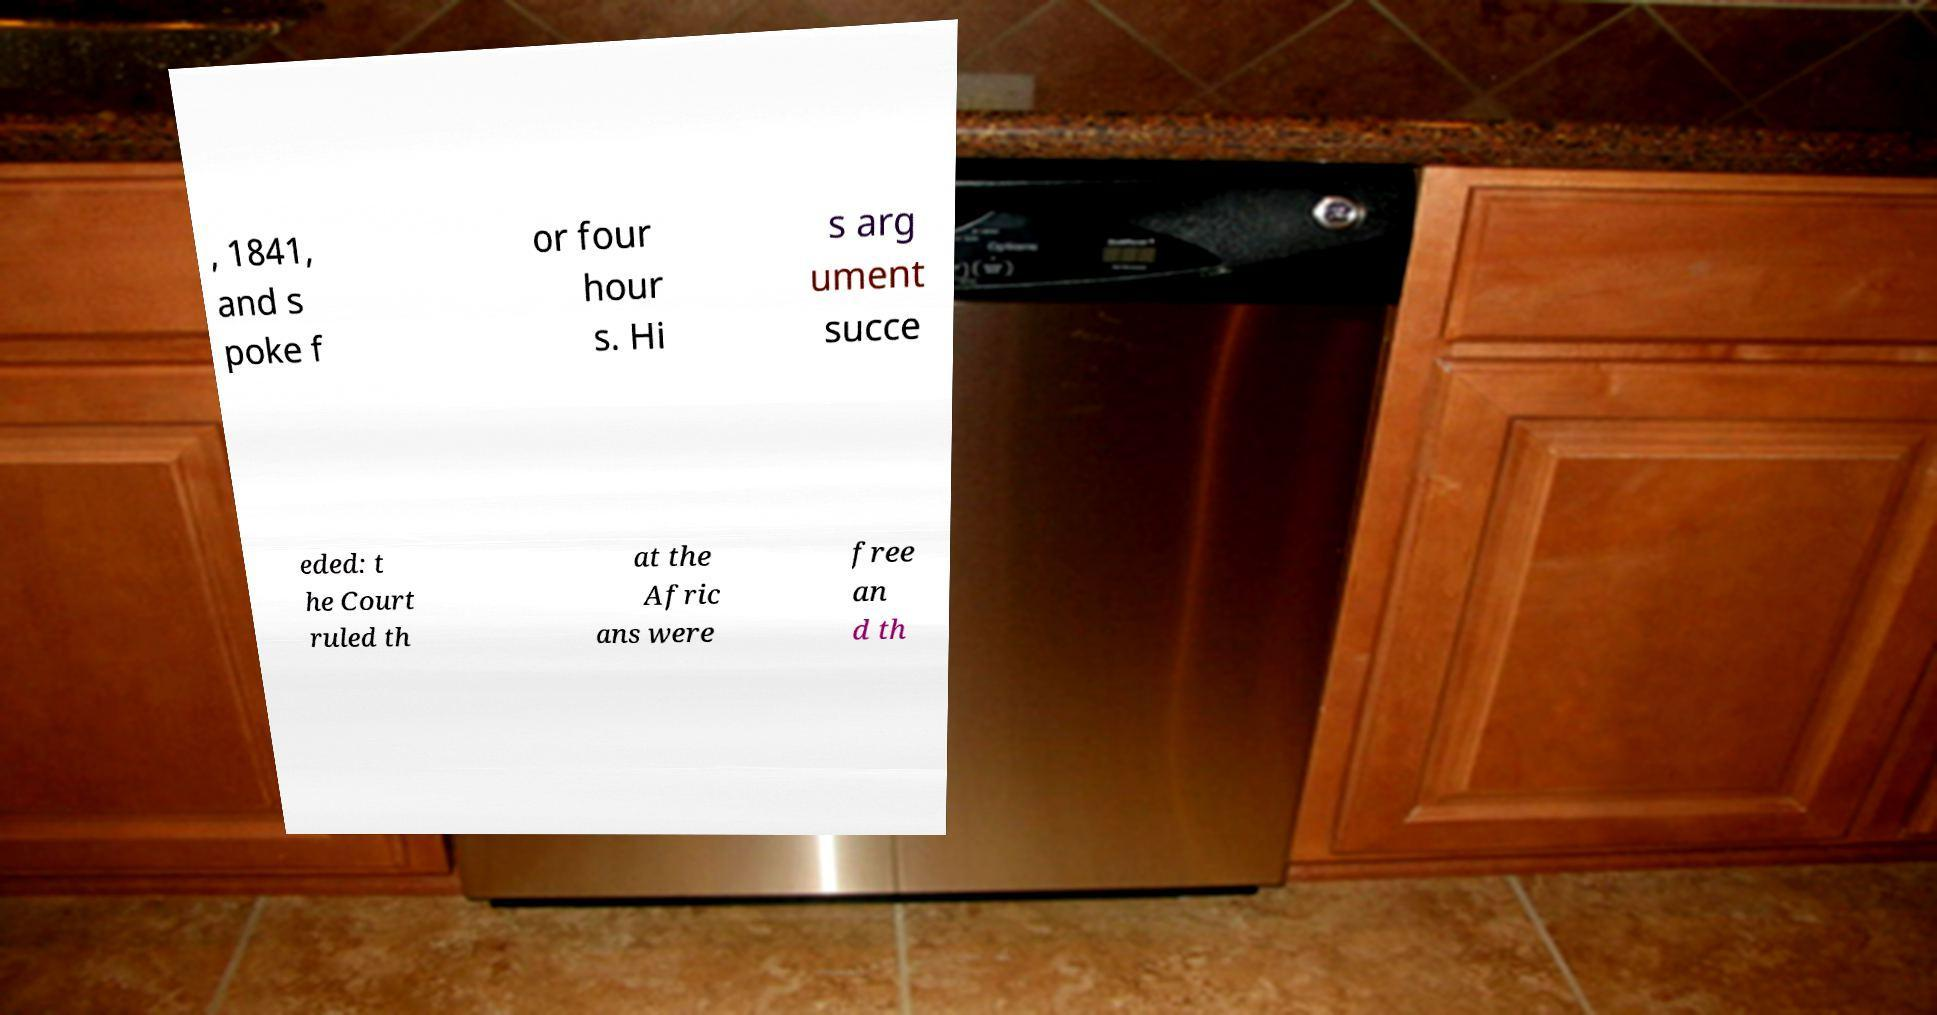There's text embedded in this image that I need extracted. Can you transcribe it verbatim? , 1841, and s poke f or four hour s. Hi s arg ument succe eded: t he Court ruled th at the Afric ans were free an d th 